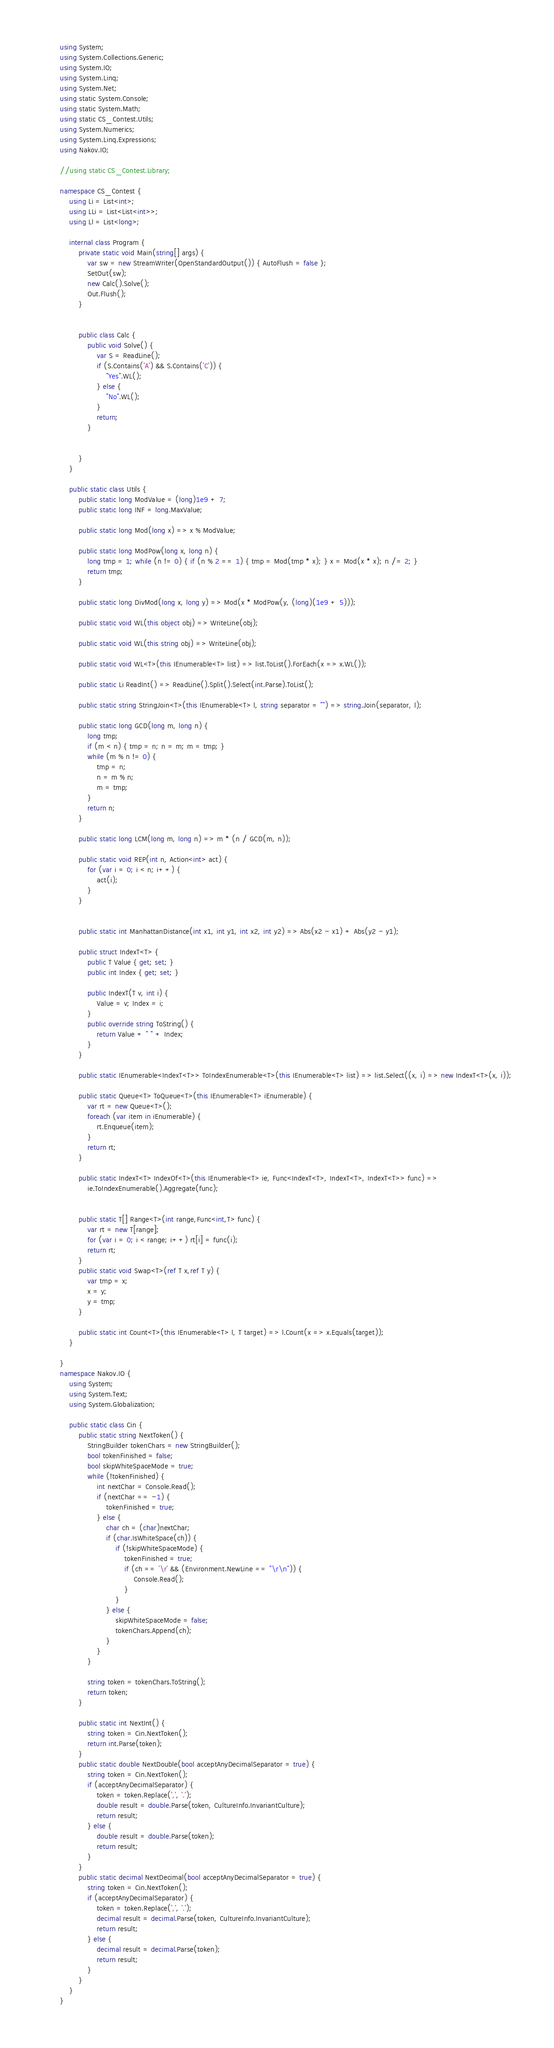<code> <loc_0><loc_0><loc_500><loc_500><_C#_>using System;
using System.Collections.Generic;
using System.IO;
using System.Linq;
using System.Net;
using static System.Console;
using static System.Math;
using static CS_Contest.Utils;
using System.Numerics;
using System.Linq.Expressions;
using Nakov.IO;

//using static CS_Contest.Library;

namespace CS_Contest {
	using Li = List<int>;
	using LLi = List<List<int>>;
	using Ll = List<long>;

	internal class Program {
		private static void Main(string[] args) {
			var sw = new StreamWriter(OpenStandardOutput()) { AutoFlush = false };
			SetOut(sw);
			new Calc().Solve();
			Out.Flush();
		}
		

		public class Calc {
			public void Solve() {
				var S = ReadLine();
				if (S.Contains('A') && S.Contains('C')) {
					"Yes".WL();
				} else {
					"No".WL();
				}
				return;
			}


		}
	}

	public static class Utils {
		public static long ModValue = (long)1e9 + 7;
		public static long INF = long.MaxValue;

		public static long Mod(long x) => x % ModValue;

		public static long ModPow(long x, long n) {
			long tmp = 1; while (n != 0) { if (n % 2 == 1) { tmp = Mod(tmp * x); } x = Mod(x * x); n /= 2; }
			return tmp;
		}

		public static long DivMod(long x, long y) => Mod(x * ModPow(y, (long)(1e9 + 5)));

		public static void WL(this object obj) => WriteLine(obj);

		public static void WL(this string obj) => WriteLine(obj);

		public static void WL<T>(this IEnumerable<T> list) => list.ToList().ForEach(x => x.WL());

		public static Li ReadInt() => ReadLine().Split().Select(int.Parse).ToList();

		public static string StringJoin<T>(this IEnumerable<T> l, string separator = "") => string.Join(separator, l);

		public static long GCD(long m, long n) {
			long tmp;
			if (m < n) { tmp = n; n = m; m = tmp; }
			while (m % n != 0) {
				tmp = n;
				n = m % n;
				m = tmp;
			}
			return n;
		}

		public static long LCM(long m, long n) => m * (n / GCD(m, n));

		public static void REP(int n, Action<int> act) {
			for (var i = 0; i < n; i++) {
				act(i);
			}
		}


		public static int ManhattanDistance(int x1, int y1, int x2, int y2) => Abs(x2 - x1) + Abs(y2 - y1);

		public struct IndexT<T> {
			public T Value { get; set; }
			public int Index { get; set; }

			public IndexT(T v, int i) {
				Value = v; Index = i;
			}
			public override string ToString() {
				return Value + " " + Index;
			}
		}

		public static IEnumerable<IndexT<T>> ToIndexEnumerable<T>(this IEnumerable<T> list) => list.Select((x, i) => new IndexT<T>(x, i));

		public static Queue<T> ToQueue<T>(this IEnumerable<T> iEnumerable) {
			var rt = new Queue<T>();
			foreach (var item in iEnumerable) {
				rt.Enqueue(item);
			}
			return rt;
		}

		public static IndexT<T> IndexOf<T>(this IEnumerable<T> ie, Func<IndexT<T>, IndexT<T>, IndexT<T>> func) =>
			ie.ToIndexEnumerable().Aggregate(func);


		public static T[] Range<T>(int range,Func<int,T> func) {
			var rt = new T[range];
			for (var i = 0; i < range; i++) rt[i] = func(i);
			return rt;
		}
		public static void Swap<T>(ref T x,ref T y) {
			var tmp = x;
			x = y;
			y = tmp;
		}

		public static int Count<T>(this IEnumerable<T> l, T target) => l.Count(x => x.Equals(target));
	}

}
namespace Nakov.IO {
	using System;
	using System.Text;
	using System.Globalization;

	public static class Cin {
		public static string NextToken() {
			StringBuilder tokenChars = new StringBuilder();
			bool tokenFinished = false;
			bool skipWhiteSpaceMode = true;
			while (!tokenFinished) {
				int nextChar = Console.Read();
				if (nextChar == -1) {
					tokenFinished = true;
				} else {
					char ch = (char)nextChar;
					if (char.IsWhiteSpace(ch)) {
						if (!skipWhiteSpaceMode) {
							tokenFinished = true;
							if (ch == '\r' && (Environment.NewLine == "\r\n")) {
								Console.Read();
							}
						}
					} else {
						skipWhiteSpaceMode = false;
						tokenChars.Append(ch);
					}
				}
			}

			string token = tokenChars.ToString();
			return token;
		}

		public static int NextInt() {
			string token = Cin.NextToken();
			return int.Parse(token);
		}
		public static double NextDouble(bool acceptAnyDecimalSeparator = true) {
			string token = Cin.NextToken();
			if (acceptAnyDecimalSeparator) {
				token = token.Replace(',', '.');
				double result = double.Parse(token, CultureInfo.InvariantCulture);
				return result;
			} else {
				double result = double.Parse(token);
				return result;
			}
		}
		public static decimal NextDecimal(bool acceptAnyDecimalSeparator = true) {
			string token = Cin.NextToken();
			if (acceptAnyDecimalSeparator) {
				token = token.Replace(',', '.');
				decimal result = decimal.Parse(token, CultureInfo.InvariantCulture);
				return result;
			} else {
				decimal result = decimal.Parse(token);
				return result;
			}
		}
	}
}</code> 